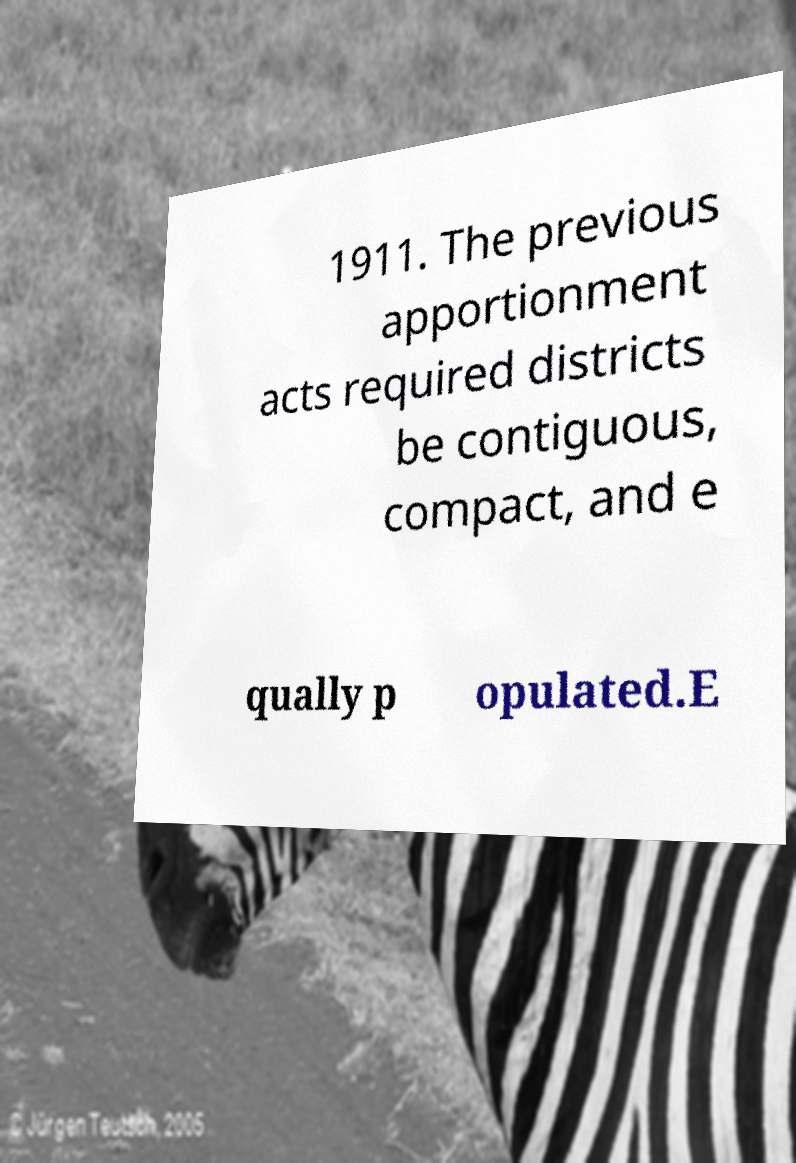I need the written content from this picture converted into text. Can you do that? 1911. The previous apportionment acts required districts be contiguous, compact, and e qually p opulated.E 